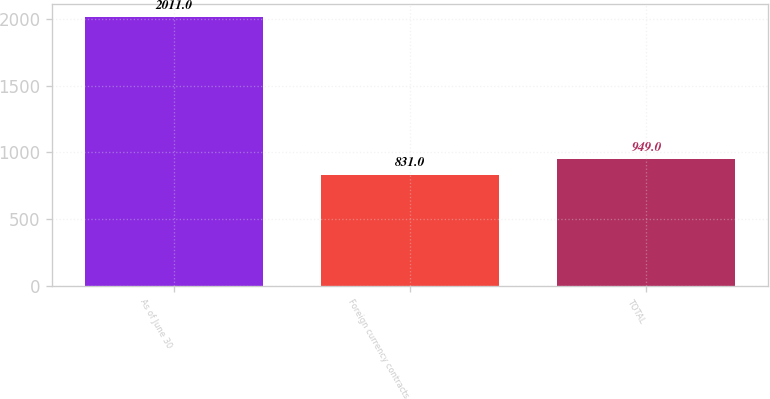<chart> <loc_0><loc_0><loc_500><loc_500><bar_chart><fcel>As of June 30<fcel>Foreign currency contracts<fcel>TOTAL<nl><fcel>2011<fcel>831<fcel>949<nl></chart> 